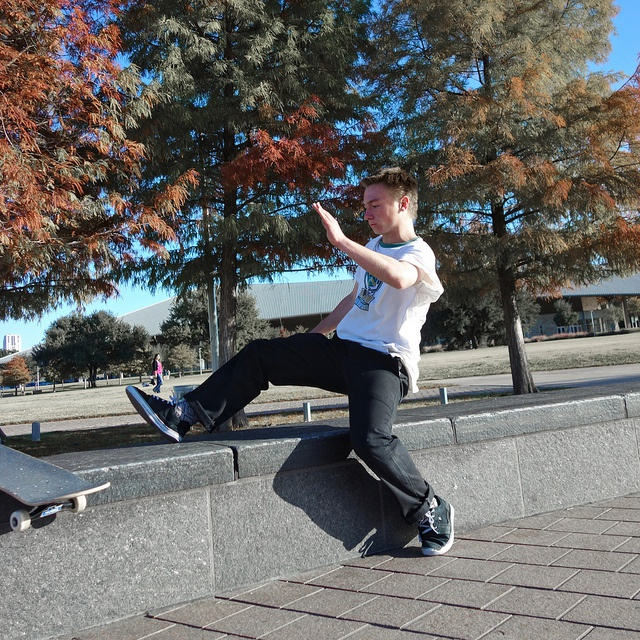Describe the objects in this image and their specific colors. I can see people in maroon, black, gray, white, and darkgray tones, skateboard in maroon, gray, and darkgray tones, and people in maroon, black, gray, darkgray, and lightgray tones in this image. 